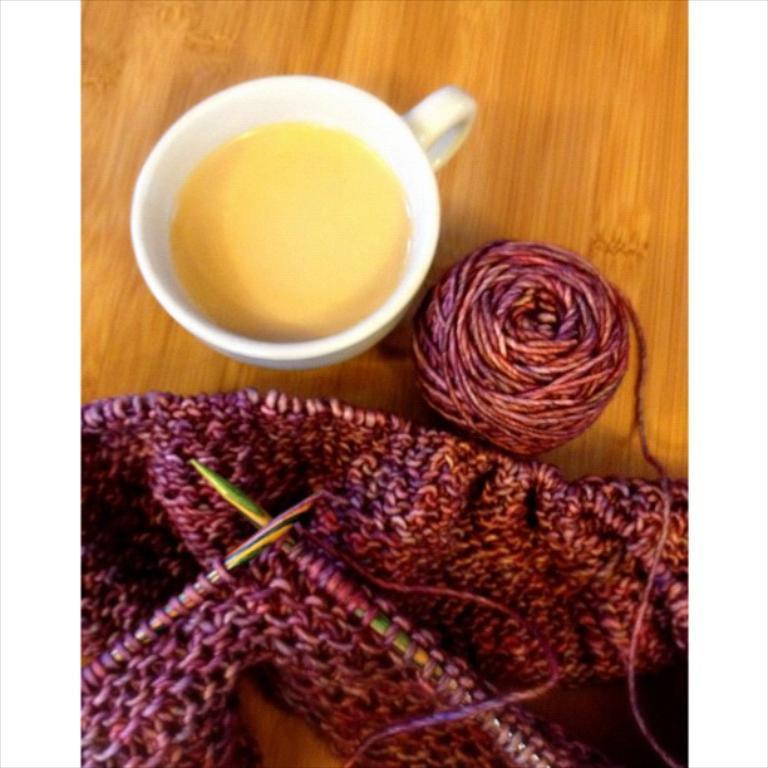How would you summarize this image in a sentence or two? In the picture we can see a wooden surface with a cup of some drink and beside it, we can see a roll of a woolen thread and beside it we can see a woolen cloth and two pins to it. 